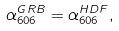<formula> <loc_0><loc_0><loc_500><loc_500>\alpha _ { 6 0 6 } ^ { G R B } = \alpha _ { 6 0 6 } ^ { H D F } ,</formula> 